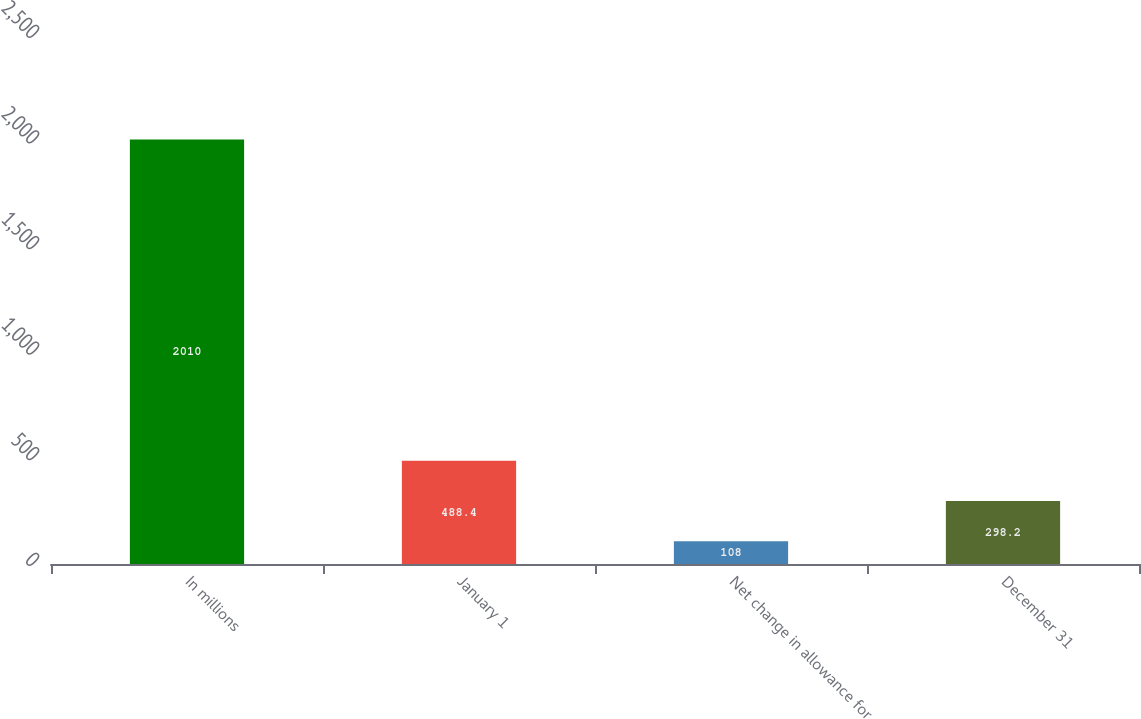Convert chart. <chart><loc_0><loc_0><loc_500><loc_500><bar_chart><fcel>In millions<fcel>January 1<fcel>Net change in allowance for<fcel>December 31<nl><fcel>2010<fcel>488.4<fcel>108<fcel>298.2<nl></chart> 